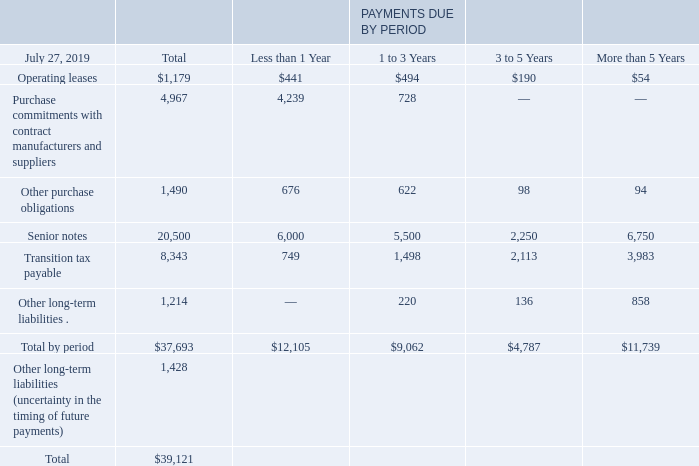Contractual Obligations
The impact of contractual obligations on our liquidity and capital resources in future periods should be analyzed in conjunction with the factors that impact our cash flows from operations discussed previously. In addition, we plan for and measure our liquidity and capital resources through an annual budgeting process. The following table summarizes our contractual obligations at July 27, 2019 (in millions):
Operating Leases For more information on our operating leases, see Note 13 to the Consolidated Financial Statements
Purchase Commitments with Contract Manufacturers and Suppliers We purchase components from a variety of suppliers and use several contract manufacturers to provide manufacturing services for our products. Our purchase commitments are for shortterm product manufacturing requirements as well as for commitments to suppliers to secure manufacturing capacity. Certain of our purchase commitments with contract manufacturers and suppliers relate to arrangements to secure long-term pricing for certain product components for multi-year periods. A significant portion of our reported estimated purchase commitments arising from these agreements are firm, noncancelable, and unconditional commitments. We record a liability for firm, noncancelable, and unconditional purchase commitments for quantities in excess of our future demand forecasts consistent with the valuation of our excess and obsolete inventory. See further discussion in “Inventory Supply Chain.” As of July 27, 2019, the liability for these purchase commitments was $129 million and is recorded in other current liabilities and is not included in the preceding table.
Other Purchase Obligations Other purchase obligations represent an estimate of all contractual obligations in the ordinary course of business, other than operating leases and commitments with contract manufacturers and suppliers, for which we have not received the goods or services. Purchase orders are not included in the preceding table as they typically represent our authorization to purchase rather than binding contractual purchase obligations.
Long-Term Debt The amount of long-term debt in the preceding table represents the principal amount of the respective debt instruments. See Note 11 to the Consolidated Financial Statements.
Transition Tax Payable Transition tax payable represents future cash tax payments associated with the one-time U.S. transition tax on accumulated earnings of foreign subsidiaries as a result of the Tax Act. See Note 17 to the Consolidated Financial Statements.
Other Long-Term Liabilities Other long-term liabilities primarily include noncurrent income taxes payable, accrued liabilities for deferred compensation, deferred tax liabilities, and certain other long-term liabilities. Due to the uncertainty in the timing of future payments, our noncurrent income taxes payable of approximately $1.3 billion and deferred tax liabilities of $95 million were presented as one aggregated amount in the total column on a separate line in the preceding table. Noncurrent income taxes payable include uncertain tax positions. See Note 17 to the Consolidated Financial Statements.
How does the company believe that their liquidity and capital resources in future periods should be analyzed? In conjunction with the factors that impact our cash flows from operations discussed previously. What was the total operating leases in 2019?
Answer scale should be: million. 1,179. What were the total other purchase obligations?
Answer scale should be: million. 1,490. What was the difference in operating leases between those that were less than 1 year and 1 to 3 years?
Answer scale should be: million. 494-441
Answer: 53. What was the total senior notes as a percentage of total contractual obligations?
Answer scale should be: percent. 20,500/39,121
Answer: 52.4. What is the period that has the greatest Operating leases? Find the largest number in row 3 COL4-7 and the corresponding time period in row 2
Answer: 1 to 3 years. 